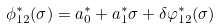<formula> <loc_0><loc_0><loc_500><loc_500>\phi _ { 1 2 } ^ { * } ( \sigma ) = a ^ { * } _ { 0 } + a ^ { * } _ { 1 } \sigma + \delta \varphi _ { 1 2 } ^ { * } ( \sigma )</formula> 